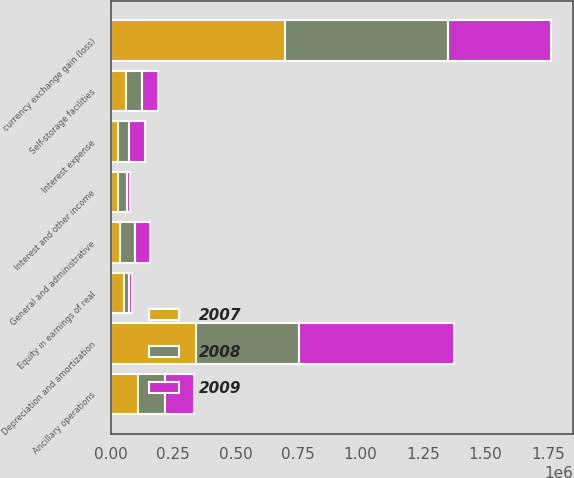Convert chart to OTSL. <chart><loc_0><loc_0><loc_500><loc_500><stacked_bar_chart><ecel><fcel>Self-storage facilities<fcel>Ancillary operations<fcel>Interest and other income<fcel>Depreciation and amortization<fcel>General and administrative<fcel>Interest expense<fcel>currency exchange gain (loss)<fcel>Equity in earnings of real<nl><fcel>2007<fcel>62809<fcel>107597<fcel>29813<fcel>340233<fcel>35735<fcel>29916<fcel>698879<fcel>53244<nl><fcel>2008<fcel>62809<fcel>108421<fcel>36155<fcel>411981<fcel>62809<fcel>43944<fcel>649241<fcel>20391<nl><fcel>2009<fcel>62809<fcel>115481<fcel>11417<fcel>619598<fcel>59749<fcel>63671<fcel>413030<fcel>12738<nl></chart> 